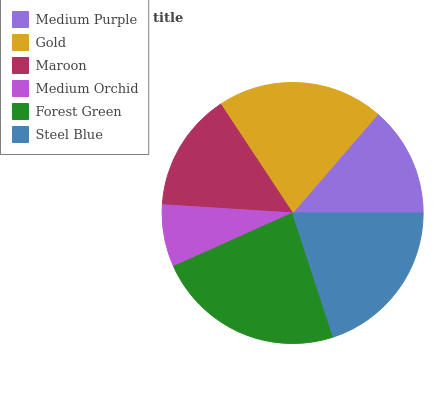Is Medium Orchid the minimum?
Answer yes or no. Yes. Is Forest Green the maximum?
Answer yes or no. Yes. Is Gold the minimum?
Answer yes or no. No. Is Gold the maximum?
Answer yes or no. No. Is Gold greater than Medium Purple?
Answer yes or no. Yes. Is Medium Purple less than Gold?
Answer yes or no. Yes. Is Medium Purple greater than Gold?
Answer yes or no. No. Is Gold less than Medium Purple?
Answer yes or no. No. Is Steel Blue the high median?
Answer yes or no. Yes. Is Maroon the low median?
Answer yes or no. Yes. Is Medium Orchid the high median?
Answer yes or no. No. Is Gold the low median?
Answer yes or no. No. 